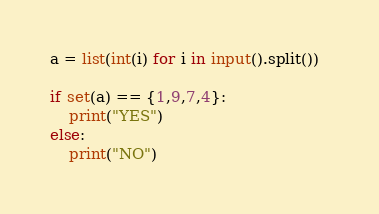<code> <loc_0><loc_0><loc_500><loc_500><_Python_>a = list(int(i) for i in input().split())  

if set(a) == {1,9,7,4}:
    print("YES")
else:
    print("NO")</code> 